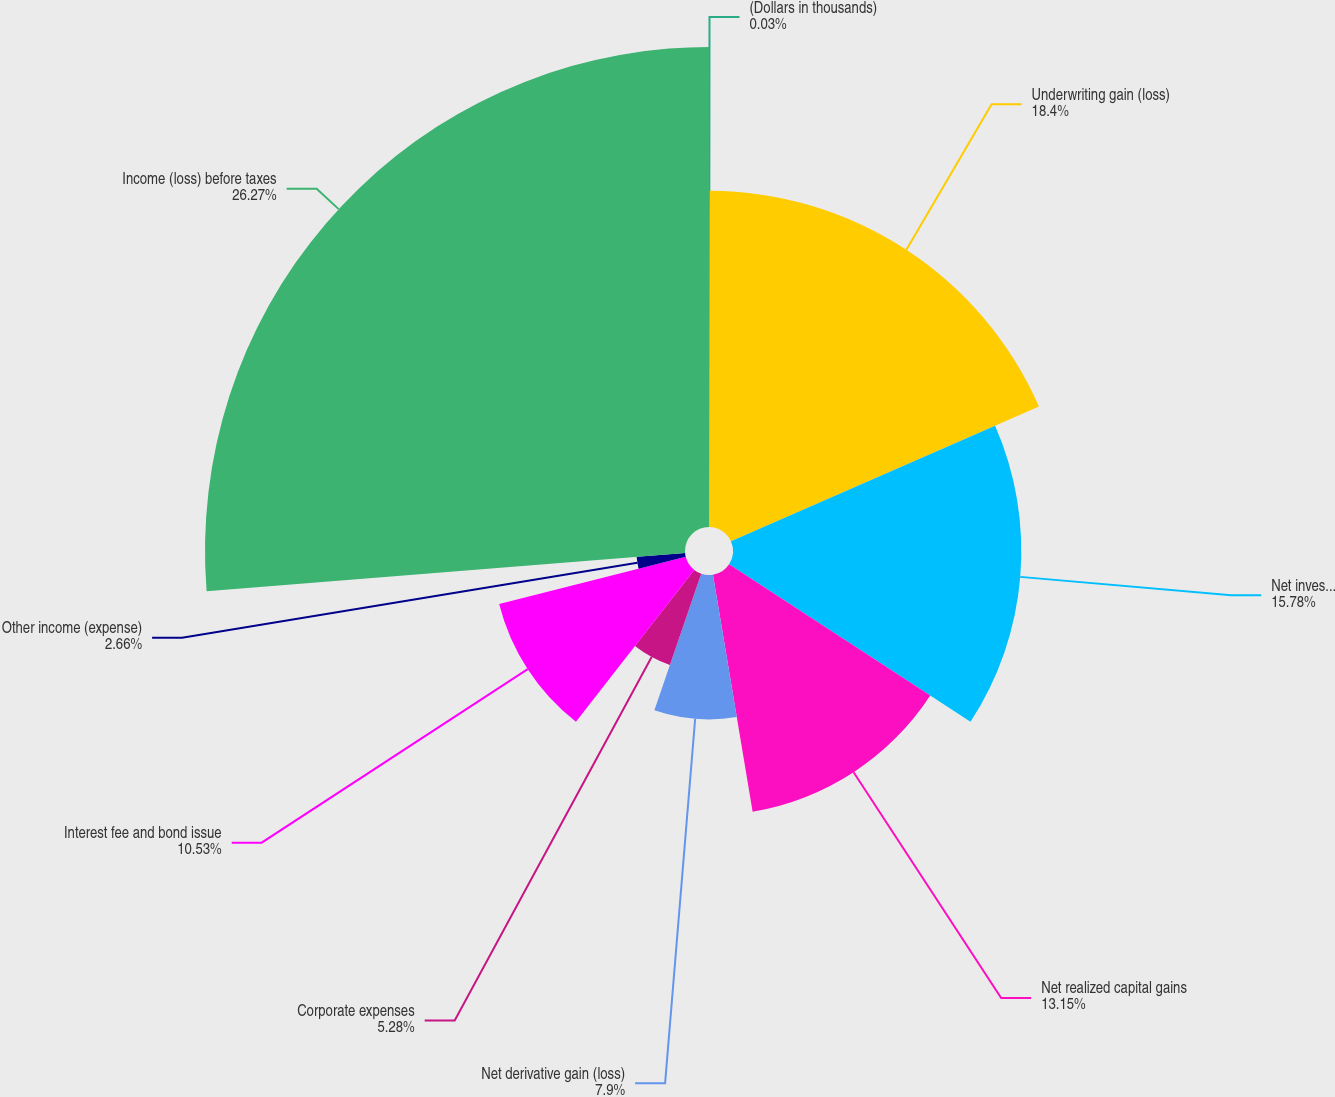Convert chart to OTSL. <chart><loc_0><loc_0><loc_500><loc_500><pie_chart><fcel>(Dollars in thousands)<fcel>Underwriting gain (loss)<fcel>Net investment income<fcel>Net realized capital gains<fcel>Net derivative gain (loss)<fcel>Corporate expenses<fcel>Interest fee and bond issue<fcel>Other income (expense)<fcel>Income (loss) before taxes<nl><fcel>0.03%<fcel>18.4%<fcel>15.78%<fcel>13.15%<fcel>7.9%<fcel>5.28%<fcel>10.53%<fcel>2.66%<fcel>26.27%<nl></chart> 